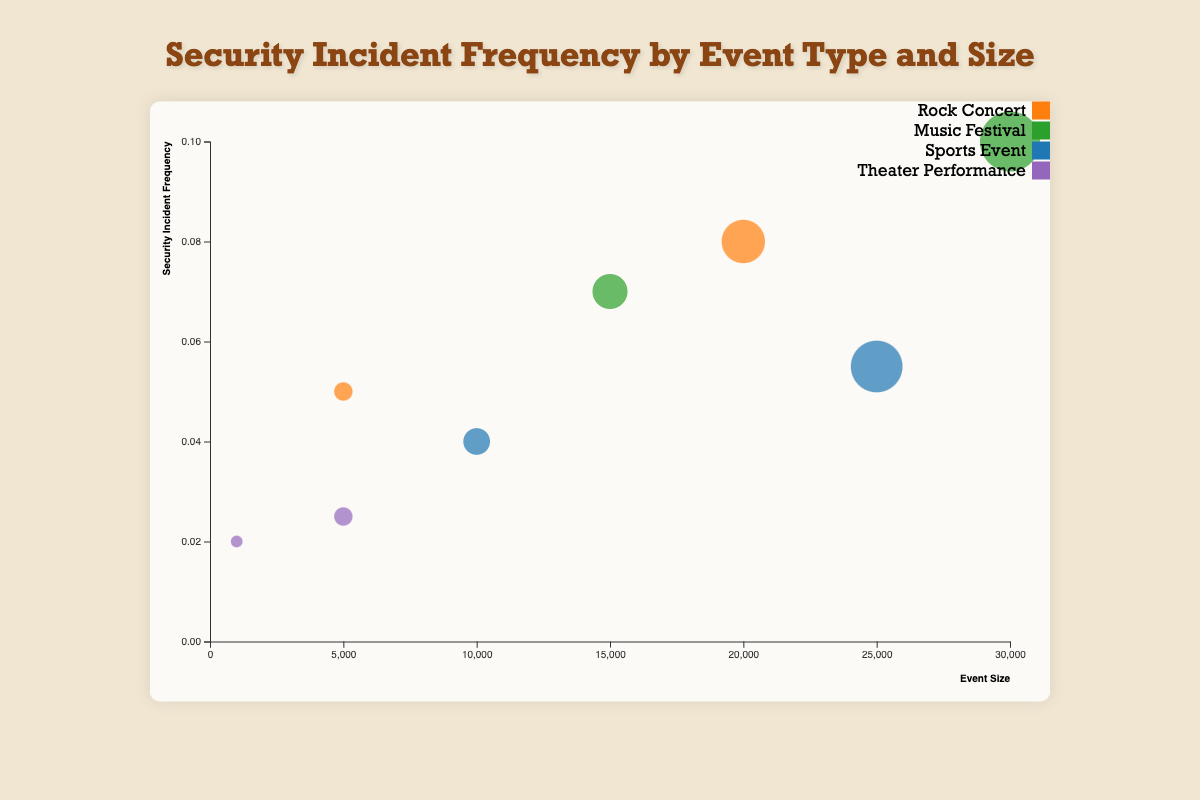What is the title of the chart? The title of the chart is usually displayed at the top of the figure. Looking at the chart, we can see the title is present in the center and is labeled clearly for context.
Answer: Security Incident Frequency by Event Type and Size Which event type has the largest bubble in the chart? The size of the bubble represents the event size. The largest bubble will correspond to the largest event size. We can observe that "Music Festival" with an event size of 30000 is the largest.
Answer: Music Festival What is the security incident frequency of the event with the smallest bubble? The smallest bubble corresponds to the smallest event size. The "Theater Performance" with an event size of 1000 is the smallest, and its security incident frequency is 0.02.
Answer: 0.02 Did any events without background checks have a security incident frequency higher than 0.05? Checking the bubbles representing events without background checks, we identify that only the "Music Festival" with an event size of 15000 and frequency of 0.07 fits this criterion.
Answer: Yes Which event type shows the least impact on security incident frequency despite increased event size? We can compare the change in security incident frequency for increasing event sizes across event types. "Theater Performance" has frequencies of 0.02 and 0.025, showing the smallest change with increased size.
Answer: Theater Performance For "Rock Concert", how does the security incident frequency change with event size? Observing the "Rock Concert" bubbles, we see frequencies of 0.05 for size 5000 and 0.08 for size 20000. Therefore, the frequency increases with event size.
Answer: Increases Compare the security incident frequency of the larger event sizes (>10000) with background checks and pat-downs. Larger events with both safety checks include "Rock Concert" (0.08), "Music Festival" (0.1), and "Sports Event" (0.055). Comparing these frequencies, the "Music Festival" has the highest at 0.1.
Answer: Music Festival Which event without pat-downs has the lowest security incident frequency? Examining events without pat-downs reveals the "Sports Event" with a size of 10000 and a frequency of 0.04 as the lowest among such events.
Answer: Sports Event 